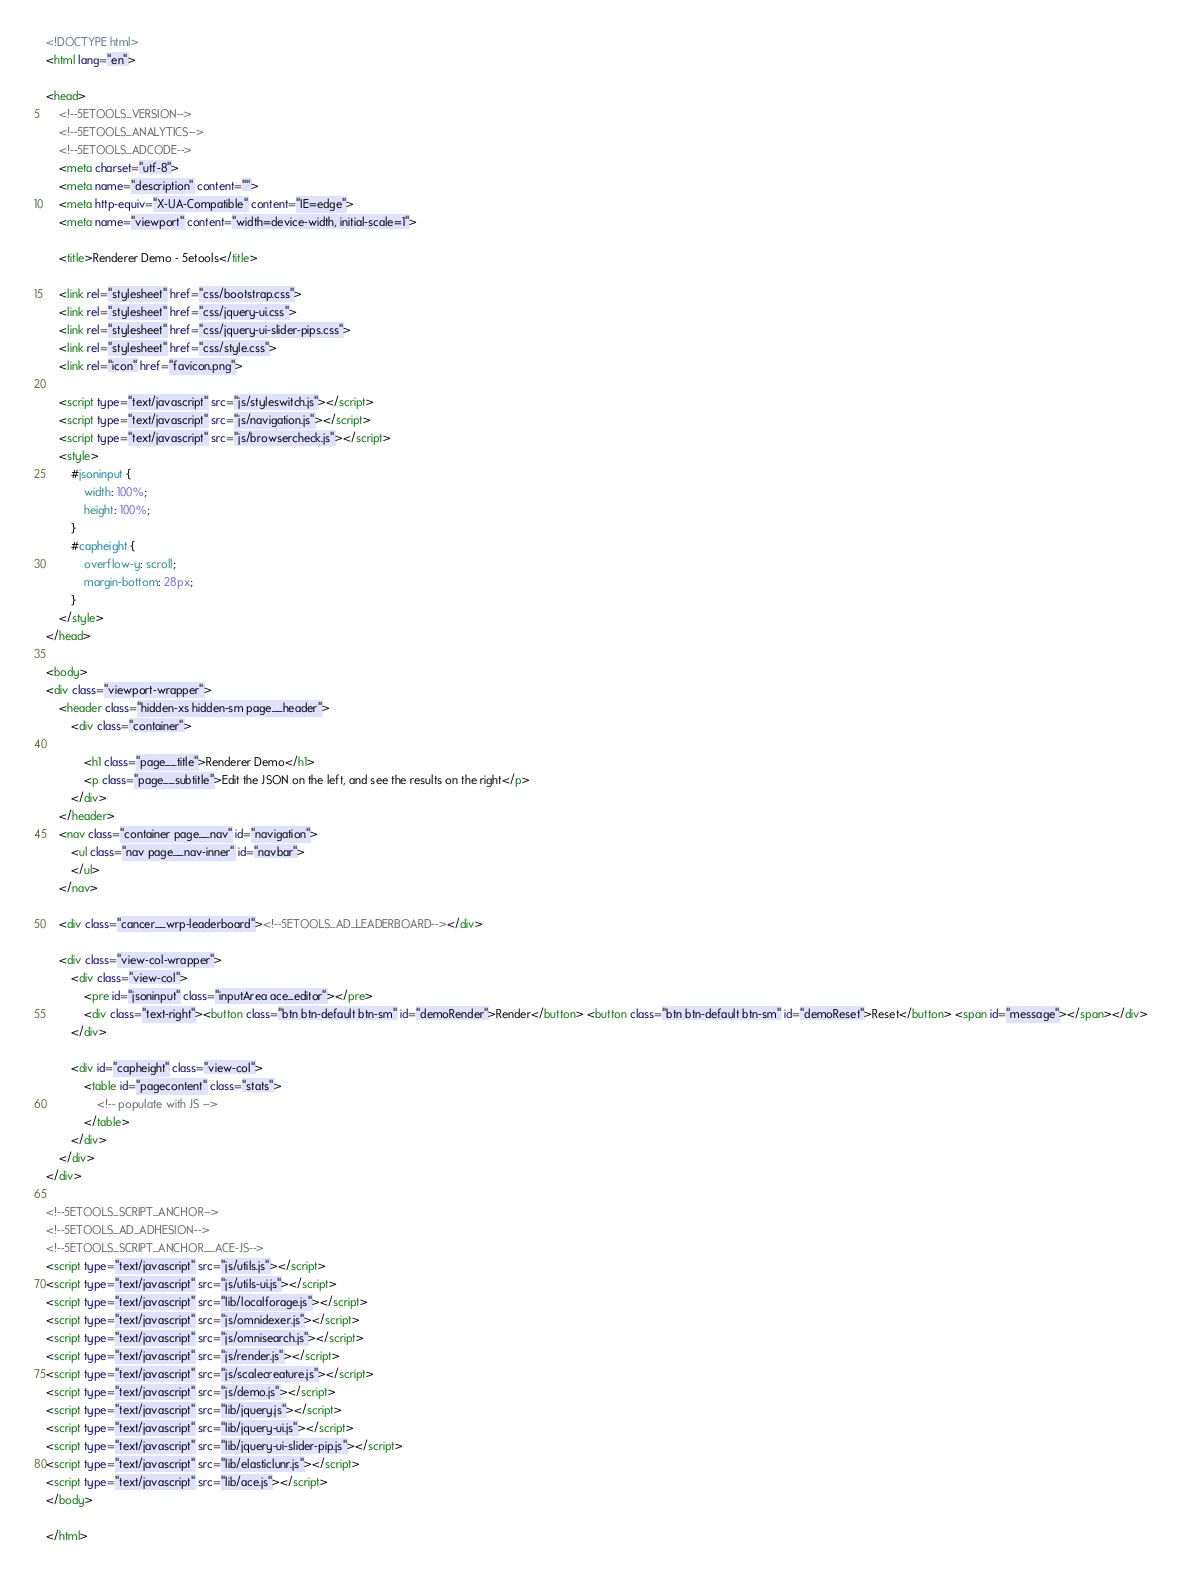<code> <loc_0><loc_0><loc_500><loc_500><_HTML_><!DOCTYPE html>
<html lang="en">

<head>
	<!--5ETOOLS_VERSION-->
	<!--5ETOOLS_ANALYTICS-->
	<!--5ETOOLS_ADCODE-->
	<meta charset="utf-8">
	<meta name="description" content="">
	<meta http-equiv="X-UA-Compatible" content="IE=edge">
	<meta name="viewport" content="width=device-width, initial-scale=1">

	<title>Renderer Demo - 5etools</title>

	<link rel="stylesheet" href="css/bootstrap.css">
	<link rel="stylesheet" href="css/jquery-ui.css">
	<link rel="stylesheet" href="css/jquery-ui-slider-pips.css">
	<link rel="stylesheet" href="css/style.css">
	<link rel="icon" href="favicon.png">

	<script type="text/javascript" src="js/styleswitch.js"></script>
	<script type="text/javascript" src="js/navigation.js"></script>
	<script type="text/javascript" src="js/browsercheck.js"></script>
	<style>
		#jsoninput {
			width: 100%;
			height: 100%;
		}
		#capheight {
			overflow-y: scroll;
			margin-bottom: 28px;
		}
	</style>
</head>

<body>
<div class="viewport-wrapper">
	<header class="hidden-xs hidden-sm page__header">
		<div class="container">

			<h1 class="page__title">Renderer Demo</h1>
			<p class="page__subtitle">Edit the JSON on the left, and see the results on the right</p>
		</div>
	</header>
	<nav class="container page__nav" id="navigation">
		<ul class="nav page__nav-inner" id="navbar">
		</ul>
	</nav>

	<div class="cancer__wrp-leaderboard"><!--5ETOOLS_AD_LEADERBOARD--></div>

	<div class="view-col-wrapper">
		<div class="view-col">
			<pre id="jsoninput" class="inputArea ace_editor"></pre>
			<div class="text-right"><button class="btn btn-default btn-sm" id="demoRender">Render</button> <button class="btn btn-default btn-sm" id="demoReset">Reset</button> <span id="message"></span></div>
		</div>

		<div id="capheight" class="view-col">
			<table id="pagecontent" class="stats">
				<!-- populate with JS -->
			</table>
		</div>
	</div>
</div>

<!--5ETOOLS_SCRIPT_ANCHOR-->
<!--5ETOOLS_AD_ADHESION-->
<!--5ETOOLS_SCRIPT_ANCHOR__ACE-JS-->
<script type="text/javascript" src="js/utils.js"></script>
<script type="text/javascript" src="js/utils-ui.js"></script>
<script type="text/javascript" src="lib/localforage.js"></script>
<script type="text/javascript" src="js/omnidexer.js"></script>
<script type="text/javascript" src="js/omnisearch.js"></script>
<script type="text/javascript" src="js/render.js"></script>
<script type="text/javascript" src="js/scalecreature.js"></script>
<script type="text/javascript" src="js/demo.js"></script>
<script type="text/javascript" src="lib/jquery.js"></script>
<script type="text/javascript" src="lib/jquery-ui.js"></script>
<script type="text/javascript" src="lib/jquery-ui-slider-pip.js"></script>
<script type="text/javascript" src="lib/elasticlunr.js"></script>
<script type="text/javascript" src="lib/ace.js"></script>
</body>

</html>
</code> 